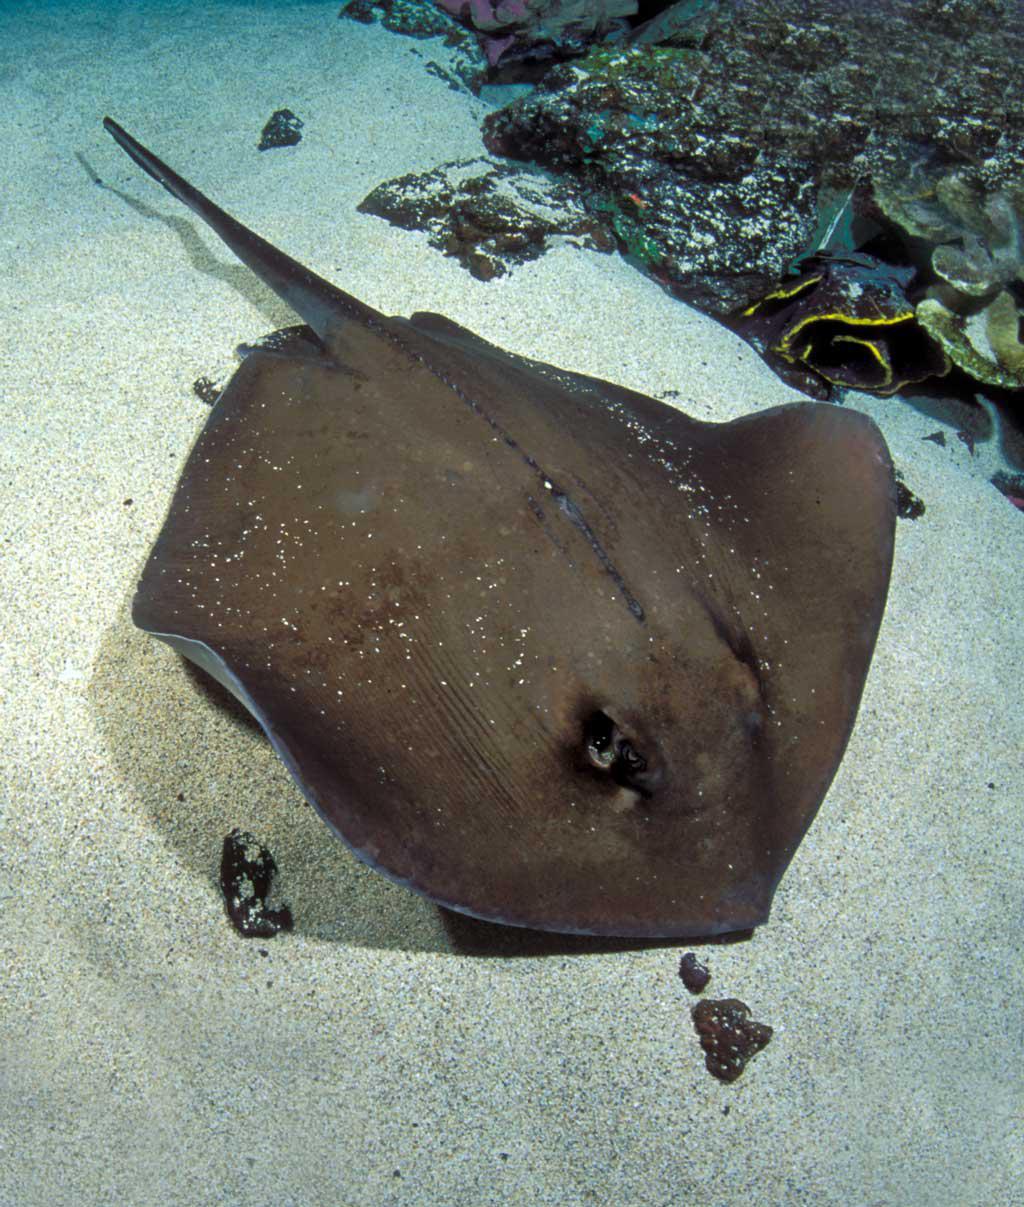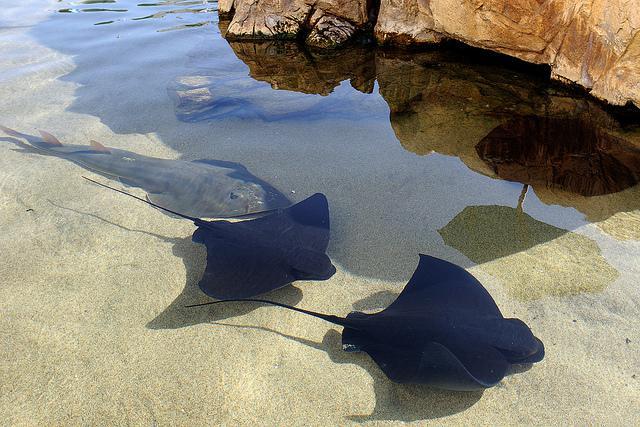The first image is the image on the left, the second image is the image on the right. For the images displayed, is the sentence "One of the rays is green and yellow with blue specks." factually correct? Answer yes or no. No. 